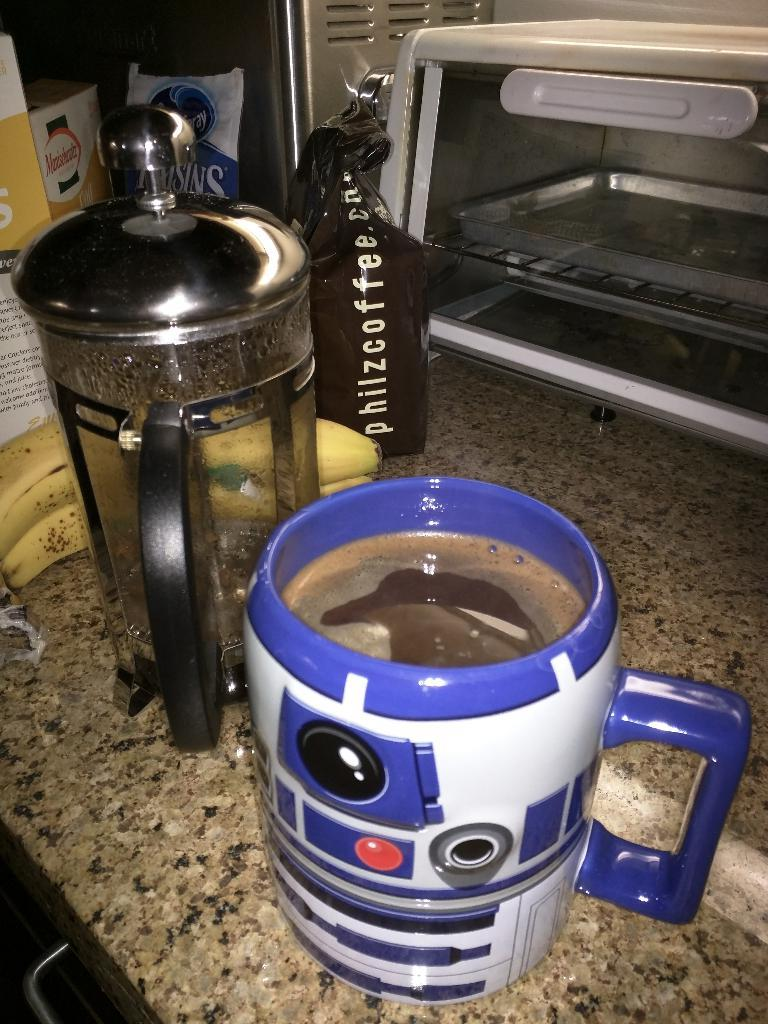Provide a one-sentence caption for the provided image. A French press and a mug of coffee sit by a bag that reads Philzcoffee. 